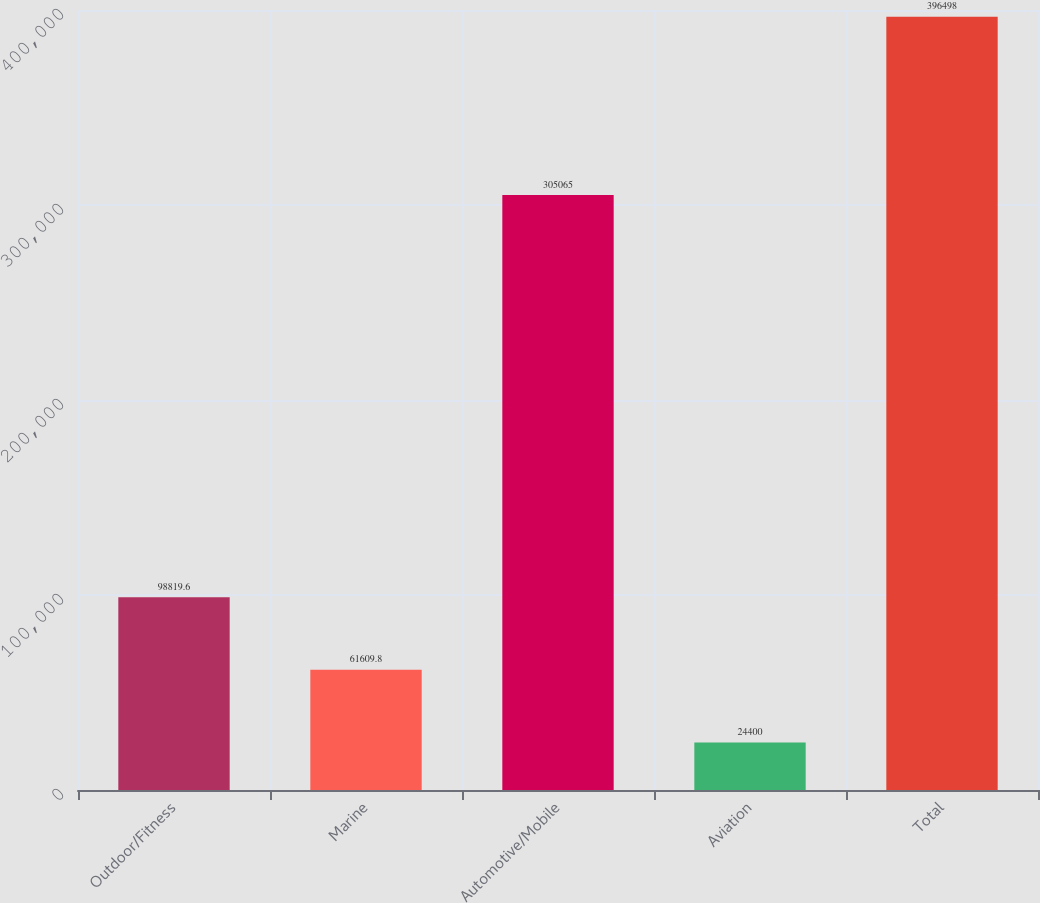Convert chart to OTSL. <chart><loc_0><loc_0><loc_500><loc_500><bar_chart><fcel>Outdoor/Fitness<fcel>Marine<fcel>Automotive/Mobile<fcel>Aviation<fcel>Total<nl><fcel>98819.6<fcel>61609.8<fcel>305065<fcel>24400<fcel>396498<nl></chart> 